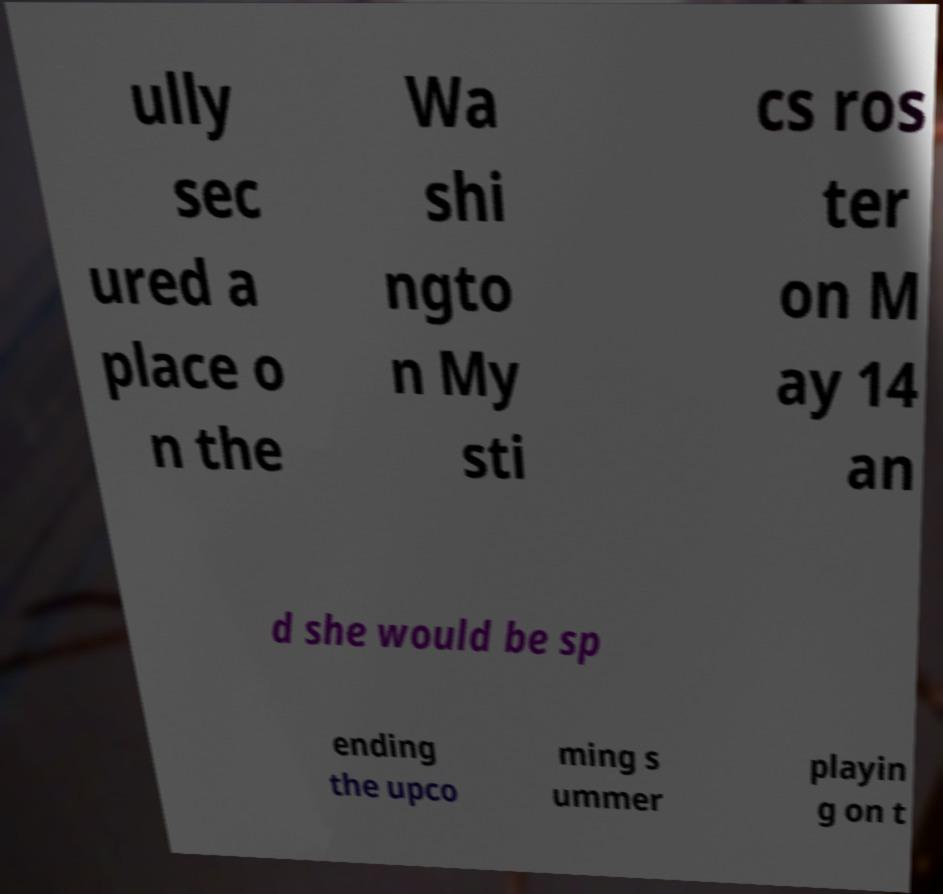Please read and relay the text visible in this image. What does it say? ully sec ured a place o n the Wa shi ngto n My sti cs ros ter on M ay 14 an d she would be sp ending the upco ming s ummer playin g on t 